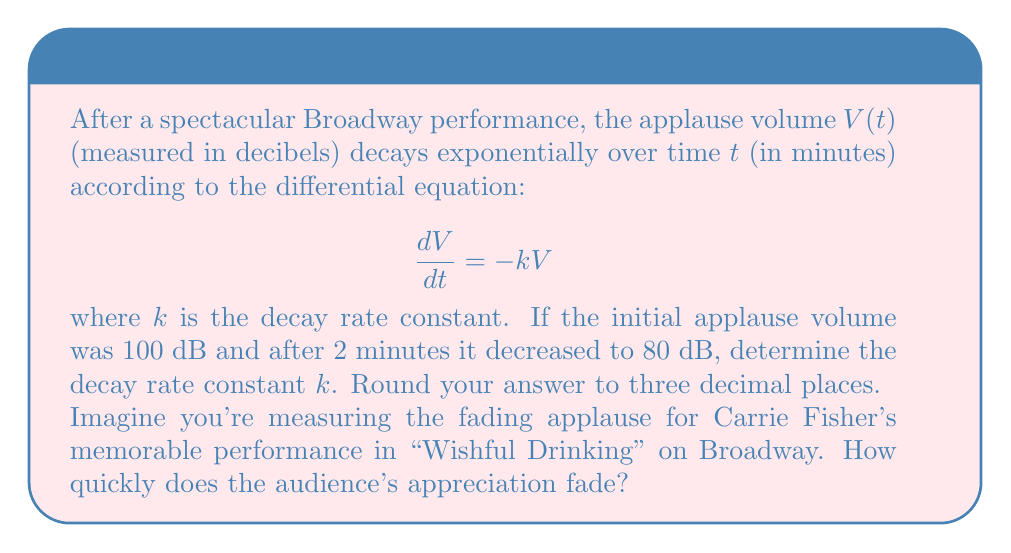What is the answer to this math problem? Let's solve this step-by-step:

1) The general solution to the differential equation $\frac{dV}{dt} = -kV$ is:

   $V(t) = V_0e^{-kt}$

   where $V_0$ is the initial volume.

2) We're given that $V_0 = 100$ dB and after 2 minutes, $V(2) = 80$ dB.

3) Let's plug these values into our equation:

   $80 = 100e^{-k(2)}$

4) Divide both sides by 100:

   $0.8 = e^{-2k}$

5) Take the natural log of both sides:

   $\ln(0.8) = -2k$

6) Solve for $k$:

   $k = -\frac{\ln(0.8)}{2}$

7) Calculate the value:

   $k = -\frac{\ln(0.8)}{2} \approx 0.11156$

8) Rounding to three decimal places:

   $k \approx 0.112$

This means the applause volume decreases by about 11.2% per minute.
Answer: $k \approx 0.112$ min$^{-1}$ 